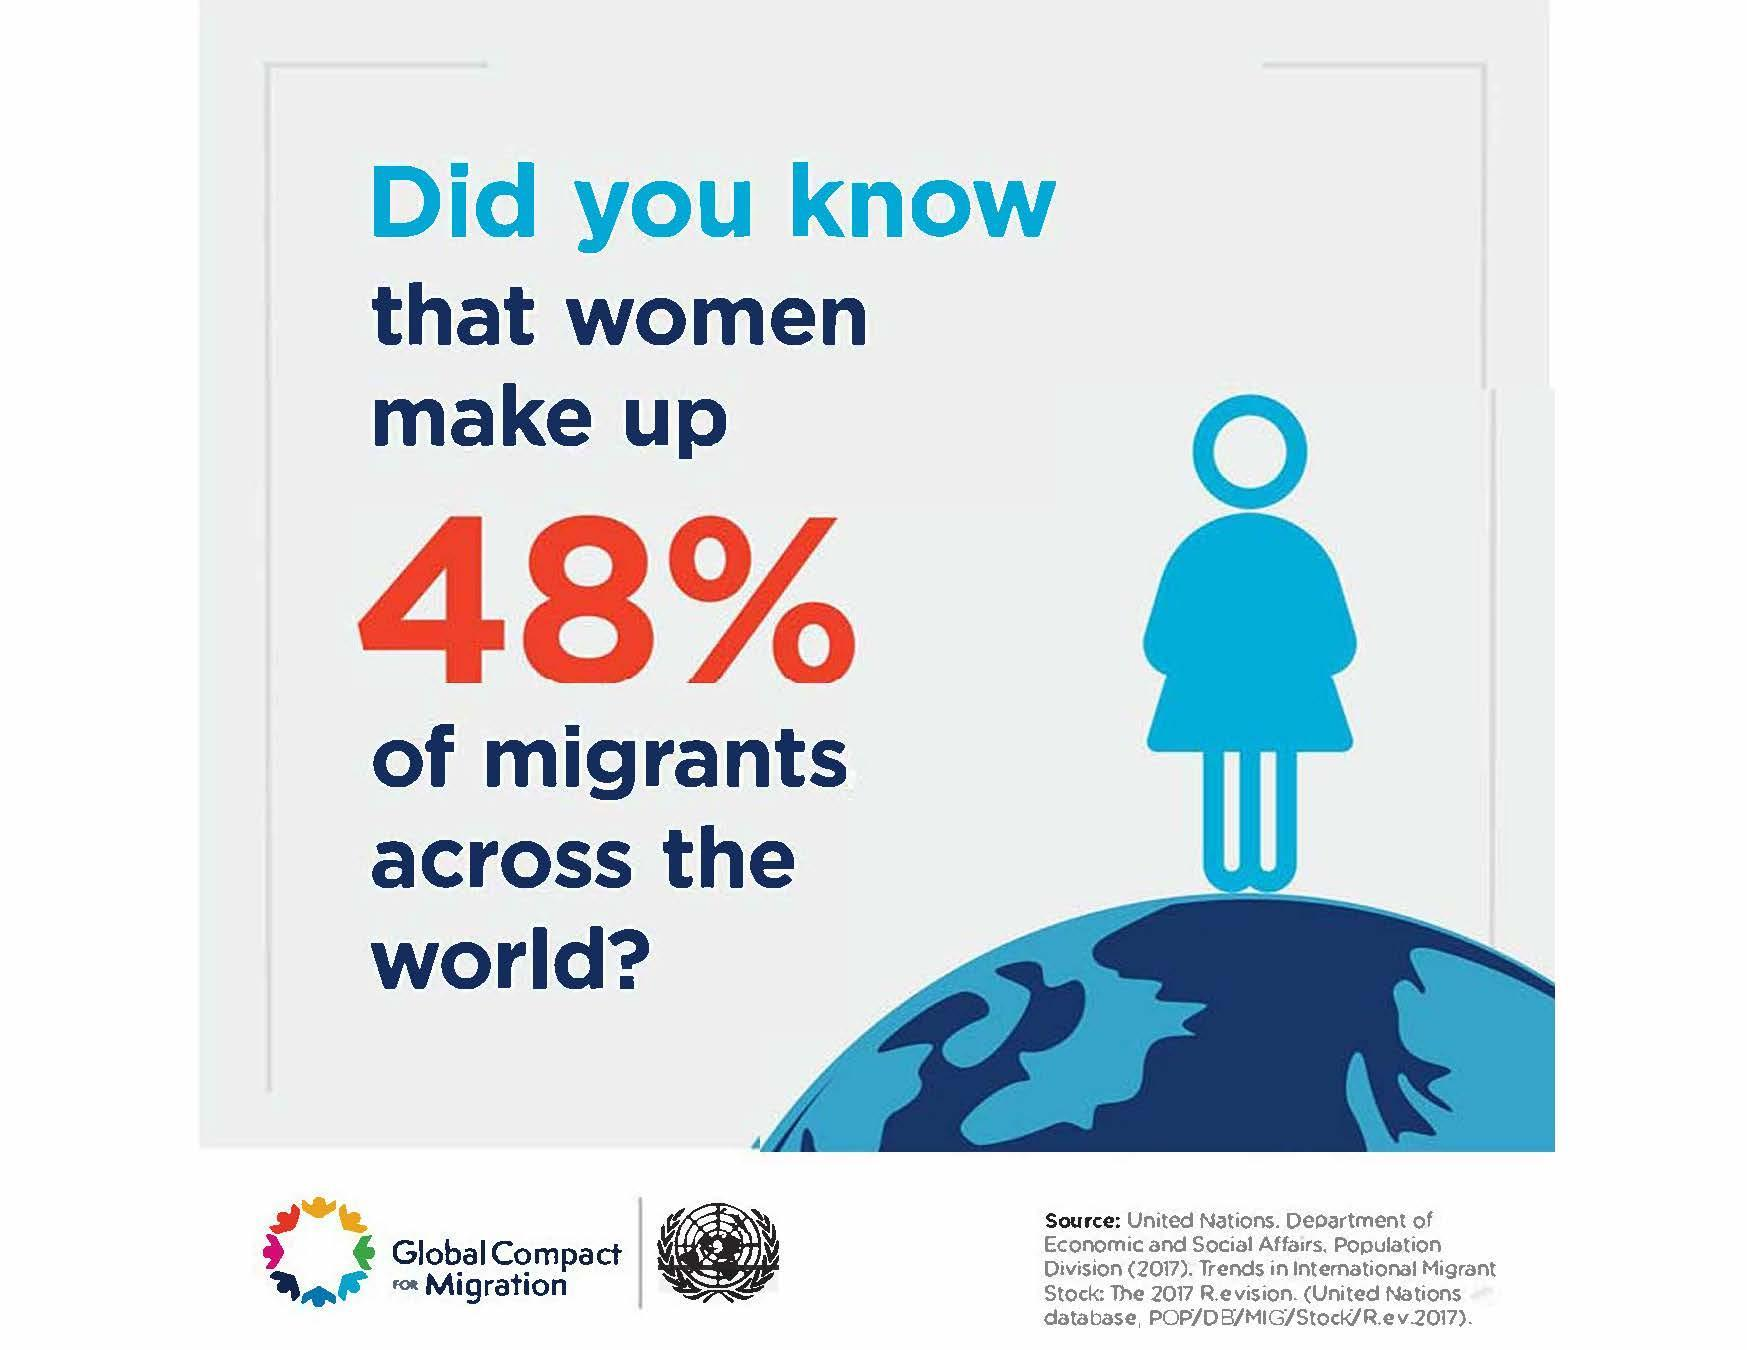What is percentage of men that make up as migrants across the world?
Answer the question with a short phrase. 52% 